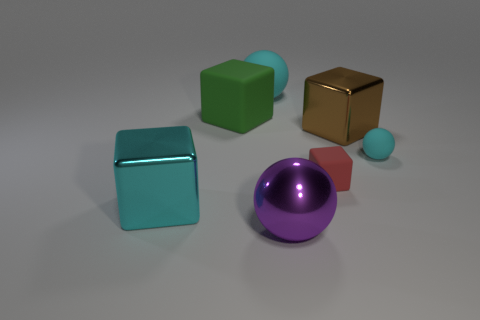There is a big purple metallic ball; how many things are to the right of it?
Keep it short and to the point. 3. The other rubber thing that is the same shape as the large green thing is what color?
Offer a very short reply. Red. What number of matte objects are either cyan objects or small brown cylinders?
Give a very brief answer. 2. There is a matte thing that is to the left of the rubber ball behind the tiny matte ball; are there any shiny cubes that are to the left of it?
Provide a succinct answer. Yes. What color is the tiny sphere?
Offer a very short reply. Cyan. Is the shape of the cyan matte thing that is to the right of the big purple ball the same as  the large brown metallic object?
Your answer should be compact. No. What number of objects are red blocks or big shiny cubes that are to the right of the green rubber thing?
Give a very brief answer. 2. Is the cyan ball that is on the right side of the brown metal thing made of the same material as the large brown object?
Your response must be concise. No. Are there any other things that have the same size as the green rubber thing?
Keep it short and to the point. Yes. There is a large object in front of the cyan thing left of the green block; what is it made of?
Give a very brief answer. Metal. 